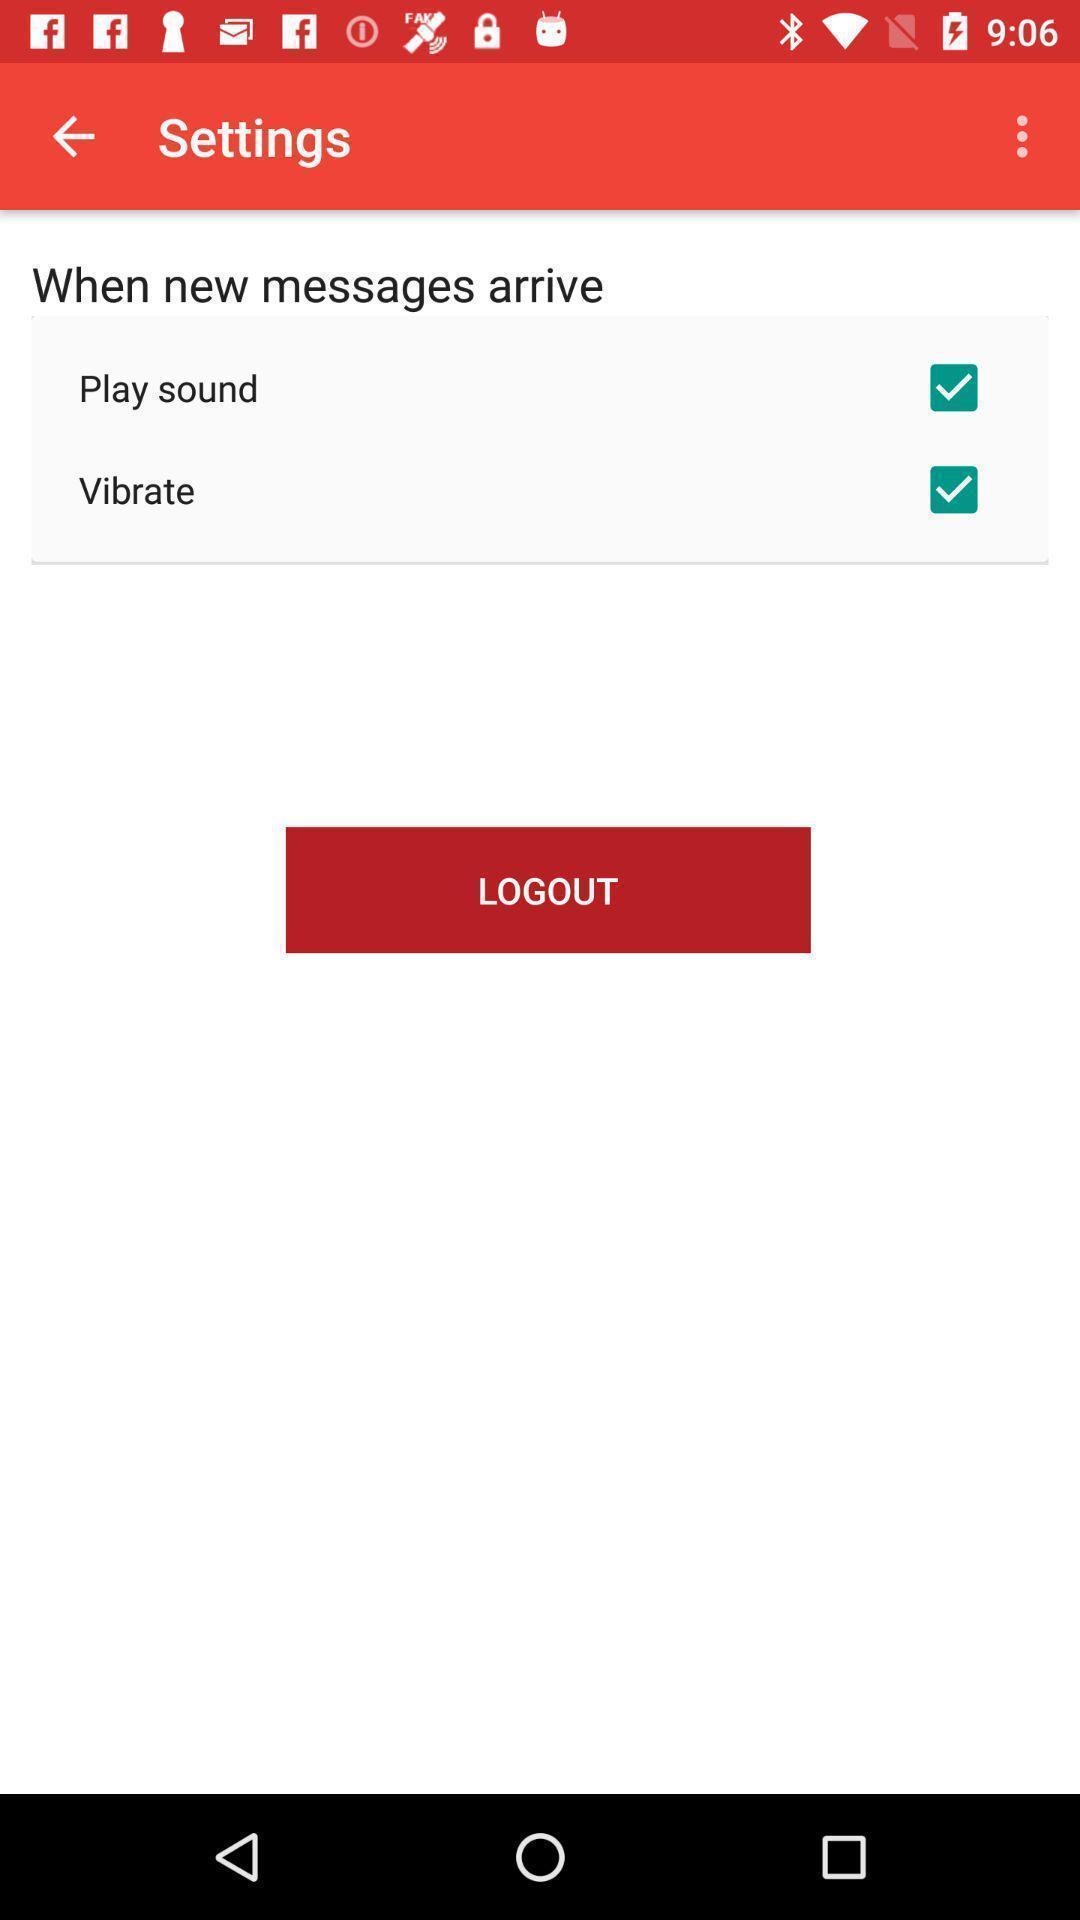Explain the elements present in this screenshot. Page displaying with different sound settings for messages. 